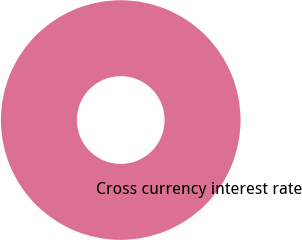Convert chart to OTSL. <chart><loc_0><loc_0><loc_500><loc_500><pie_chart><fcel>Cross currency interest rate<nl><fcel>100.0%<nl></chart> 